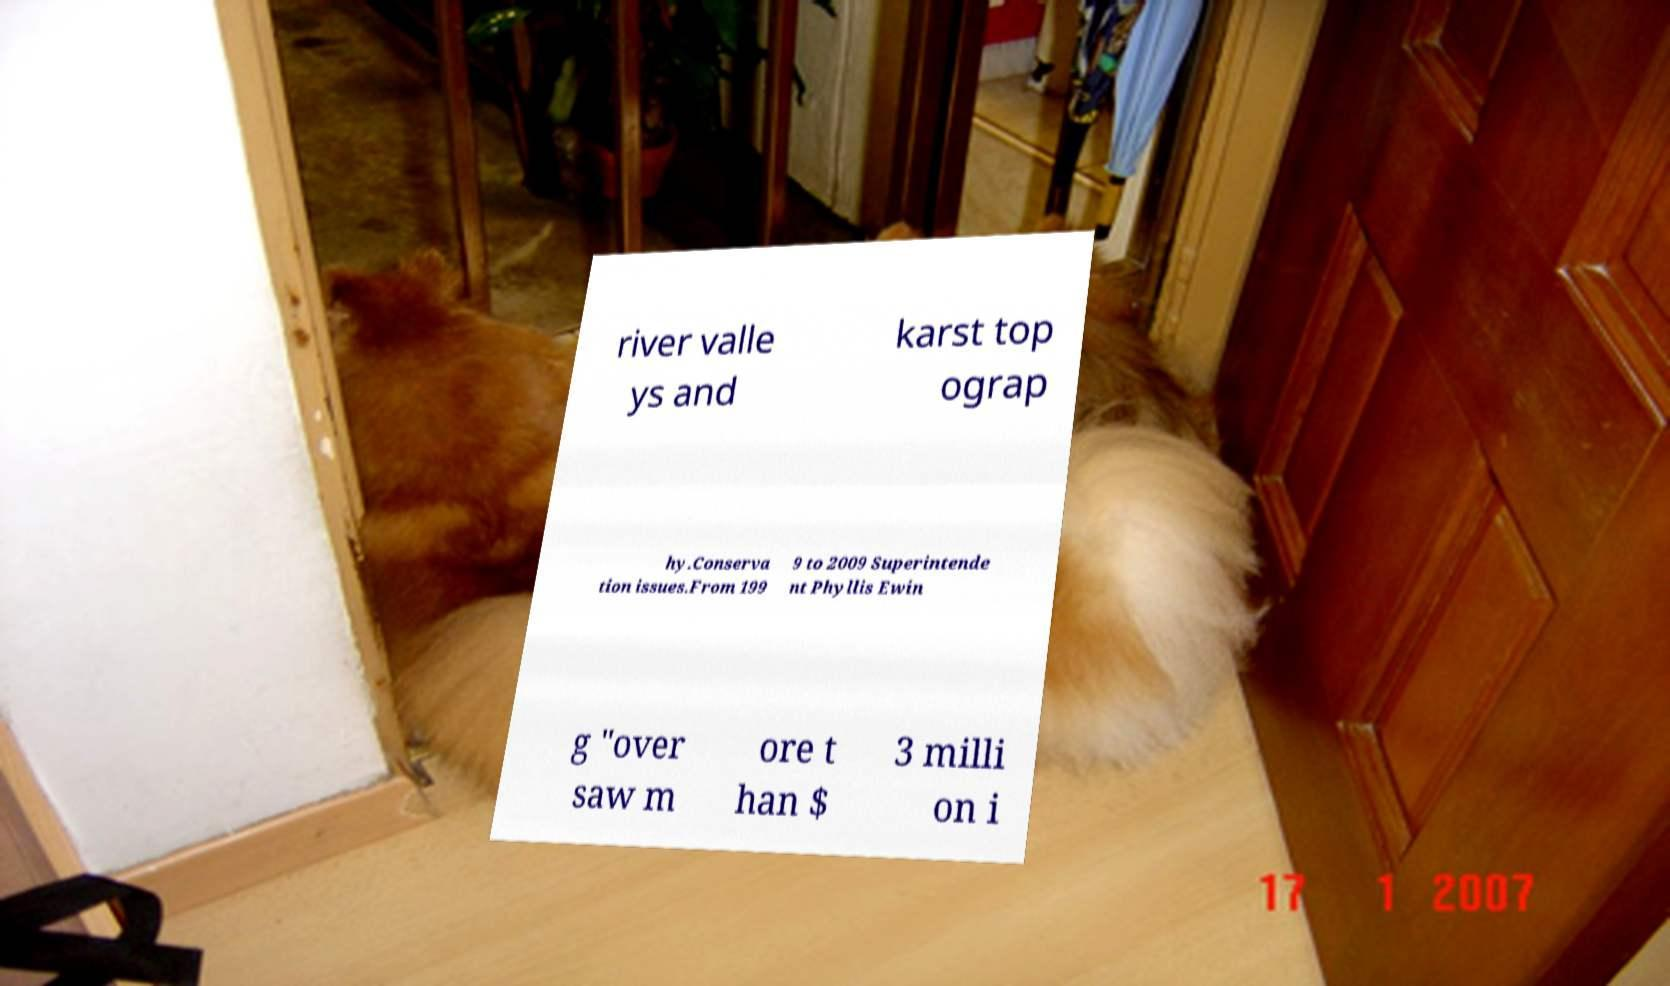What messages or text are displayed in this image? I need them in a readable, typed format. river valle ys and karst top ograp hy.Conserva tion issues.From 199 9 to 2009 Superintende nt Phyllis Ewin g "over saw m ore t han $ 3 milli on i 